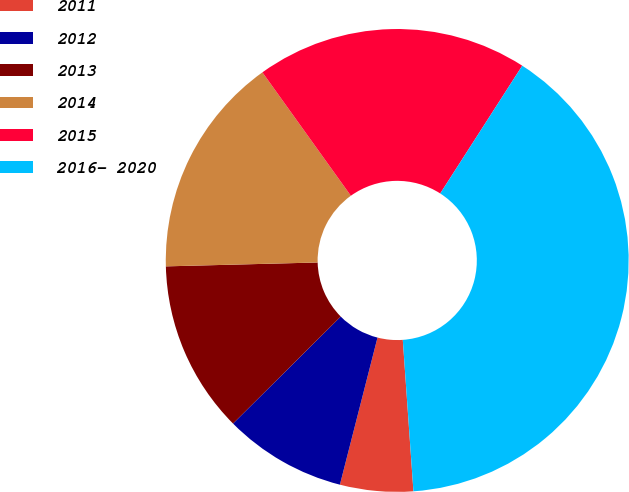Convert chart. <chart><loc_0><loc_0><loc_500><loc_500><pie_chart><fcel>2011<fcel>2012<fcel>2013<fcel>2014<fcel>2015<fcel>2016- 2020<nl><fcel>5.1%<fcel>8.57%<fcel>12.04%<fcel>15.51%<fcel>18.98%<fcel>39.8%<nl></chart> 